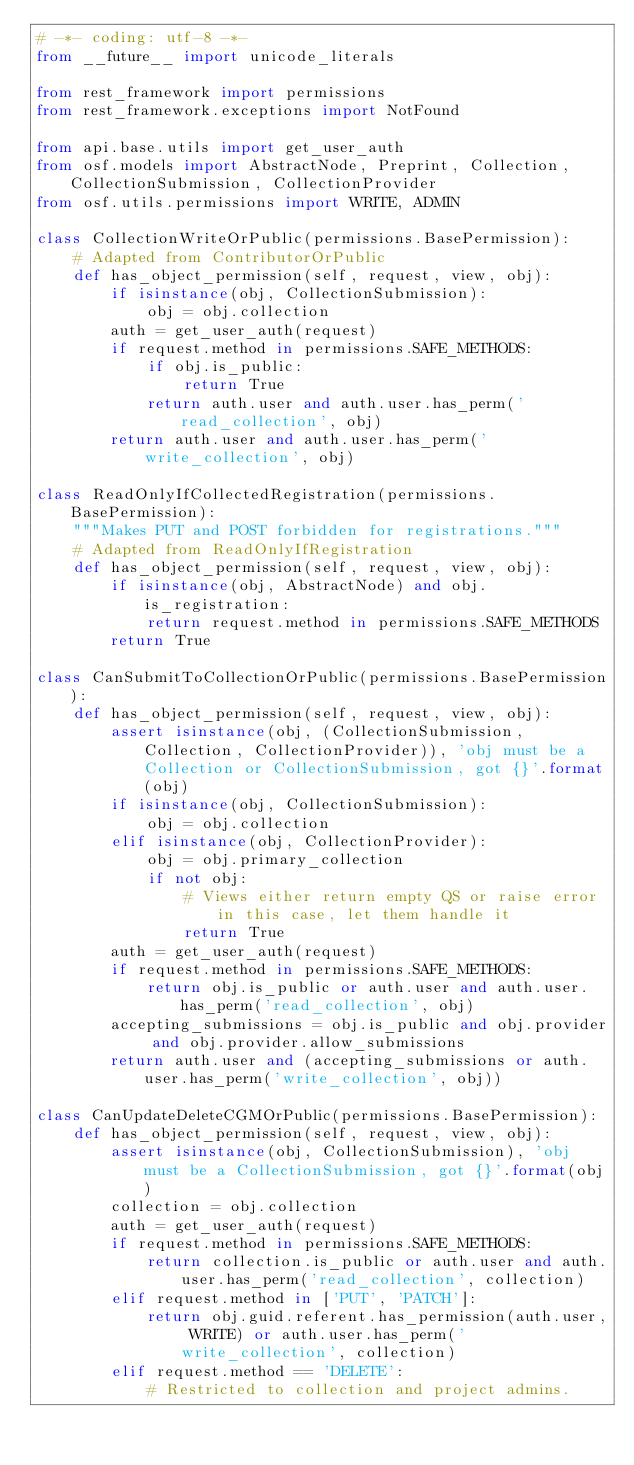<code> <loc_0><loc_0><loc_500><loc_500><_Python_># -*- coding: utf-8 -*-
from __future__ import unicode_literals

from rest_framework import permissions
from rest_framework.exceptions import NotFound

from api.base.utils import get_user_auth
from osf.models import AbstractNode, Preprint, Collection, CollectionSubmission, CollectionProvider
from osf.utils.permissions import WRITE, ADMIN

class CollectionWriteOrPublic(permissions.BasePermission):
    # Adapted from ContributorOrPublic
    def has_object_permission(self, request, view, obj):
        if isinstance(obj, CollectionSubmission):
            obj = obj.collection
        auth = get_user_auth(request)
        if request.method in permissions.SAFE_METHODS:
            if obj.is_public:
                return True
            return auth.user and auth.user.has_perm('read_collection', obj)
        return auth.user and auth.user.has_perm('write_collection', obj)

class ReadOnlyIfCollectedRegistration(permissions.BasePermission):
    """Makes PUT and POST forbidden for registrations."""
    # Adapted from ReadOnlyIfRegistration
    def has_object_permission(self, request, view, obj):
        if isinstance(obj, AbstractNode) and obj.is_registration:
            return request.method in permissions.SAFE_METHODS
        return True

class CanSubmitToCollectionOrPublic(permissions.BasePermission):
    def has_object_permission(self, request, view, obj):
        assert isinstance(obj, (CollectionSubmission, Collection, CollectionProvider)), 'obj must be a Collection or CollectionSubmission, got {}'.format(obj)
        if isinstance(obj, CollectionSubmission):
            obj = obj.collection
        elif isinstance(obj, CollectionProvider):
            obj = obj.primary_collection
            if not obj:
                # Views either return empty QS or raise error in this case, let them handle it
                return True
        auth = get_user_auth(request)
        if request.method in permissions.SAFE_METHODS:
            return obj.is_public or auth.user and auth.user.has_perm('read_collection', obj)
        accepting_submissions = obj.is_public and obj.provider and obj.provider.allow_submissions
        return auth.user and (accepting_submissions or auth.user.has_perm('write_collection', obj))

class CanUpdateDeleteCGMOrPublic(permissions.BasePermission):
    def has_object_permission(self, request, view, obj):
        assert isinstance(obj, CollectionSubmission), 'obj must be a CollectionSubmission, got {}'.format(obj)
        collection = obj.collection
        auth = get_user_auth(request)
        if request.method in permissions.SAFE_METHODS:
            return collection.is_public or auth.user and auth.user.has_perm('read_collection', collection)
        elif request.method in ['PUT', 'PATCH']:
            return obj.guid.referent.has_permission(auth.user, WRITE) or auth.user.has_perm('write_collection', collection)
        elif request.method == 'DELETE':
            # Restricted to collection and project admins.</code> 